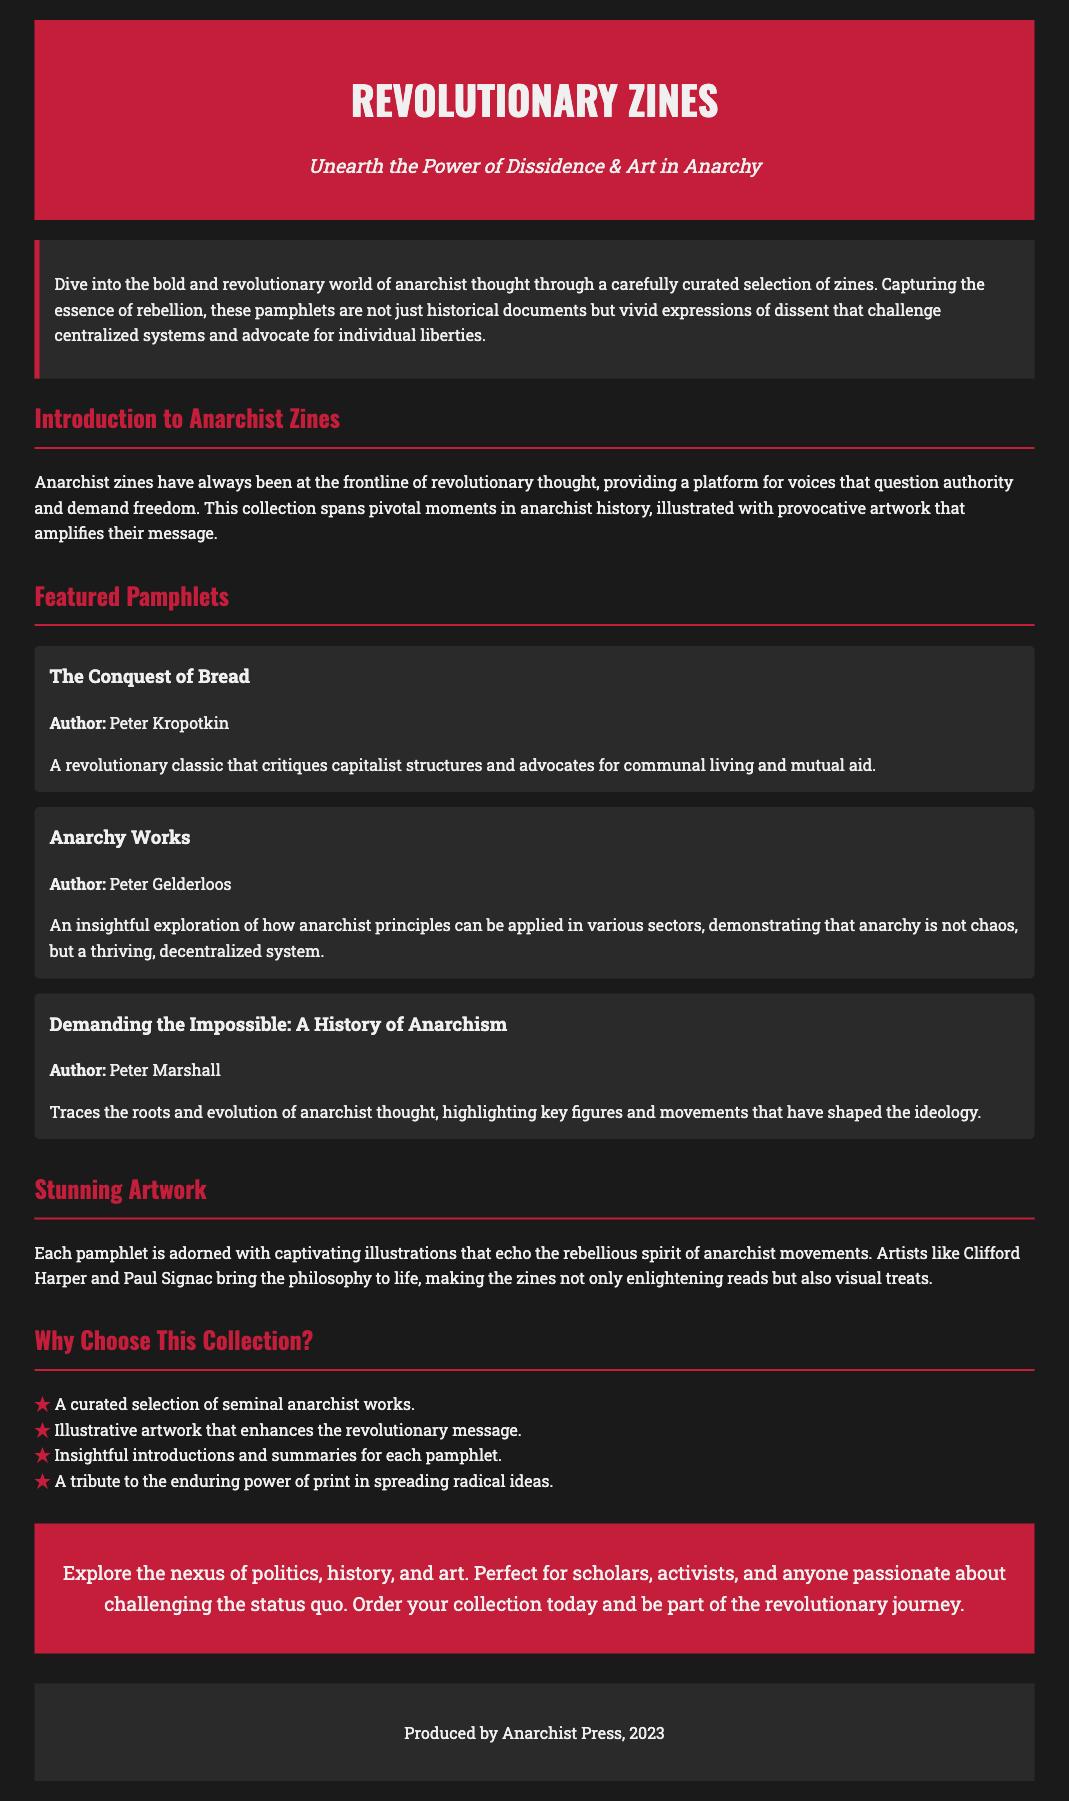What is the title of the collection? The title is prominently displayed at the top of the document as part of the header.
Answer: Revolutionary Zines Who is the author of "The Conquest of Bread"? The document includes a specific mention of the author next to each featured pamphlet.
Answer: Peter Kropotkin What is the major theme emphasized in the pamphlets? The description highlights the critical perspective and advocacy within the anarchist context.
Answer: Individual liberties Which artist's work is mentioned in the artwork section? The document specifically names an artist associated with the illustrated pamphlets.
Answer: Clifford Harper How many pamphlets are featured in the collection? The section about featured pamphlets lists three distinct titles.
Answer: Three What type of content is described as enhancing the zines? The document points out an artistic element that visually complements the messages of the zines.
Answer: Illustrative artwork What year was the collection produced? The footer provides the production year of the document.
Answer: 2023 What is the primary audience for this collection? The call-to-action describes who would benefit or be interested in this collection.
Answer: Scholars, activists, and anyone passionate about challenging the status quo 